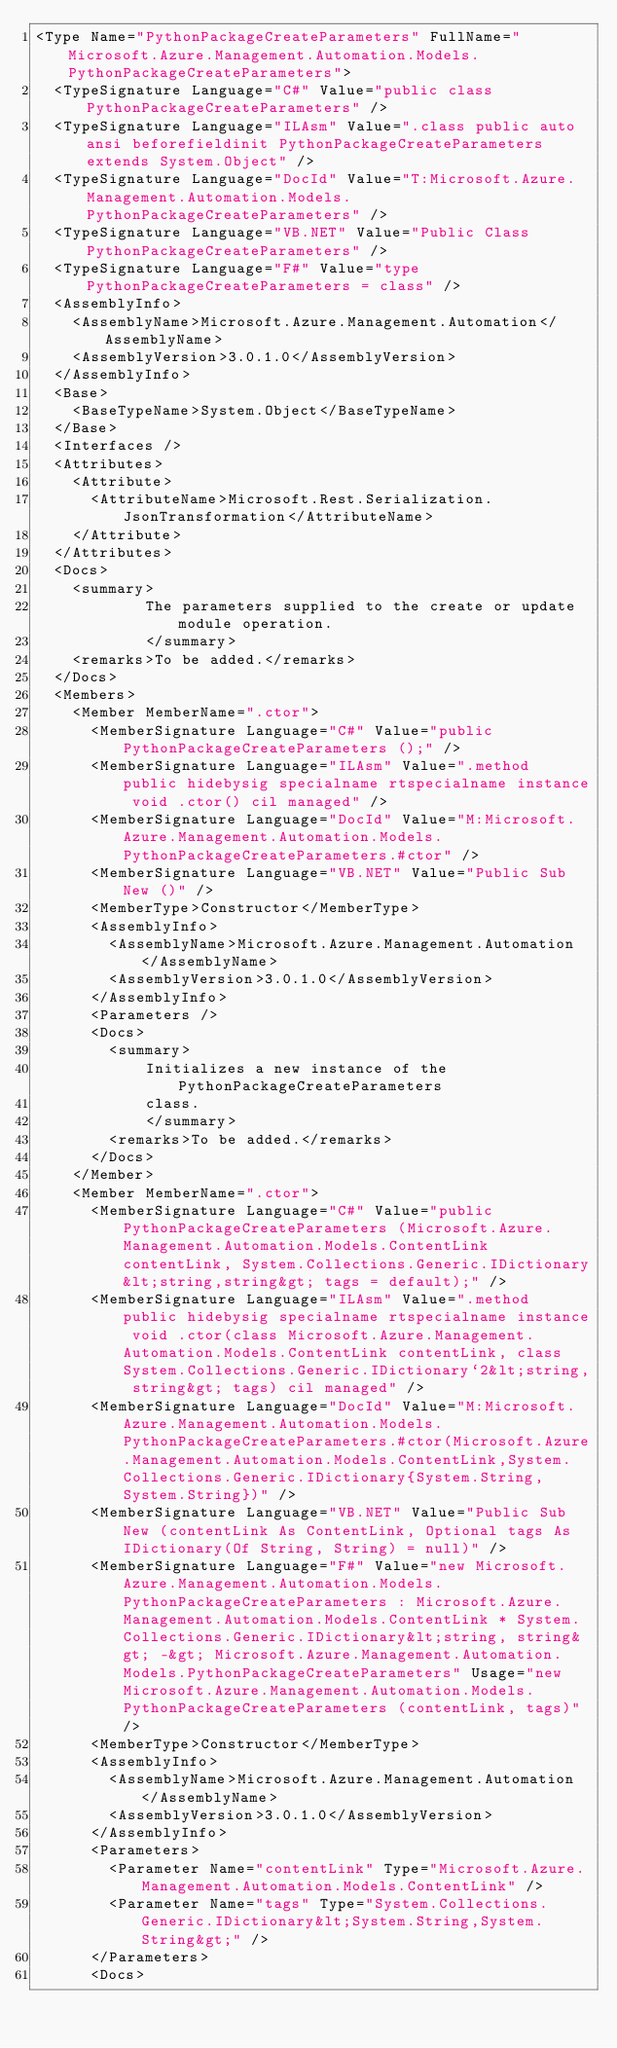<code> <loc_0><loc_0><loc_500><loc_500><_XML_><Type Name="PythonPackageCreateParameters" FullName="Microsoft.Azure.Management.Automation.Models.PythonPackageCreateParameters">
  <TypeSignature Language="C#" Value="public class PythonPackageCreateParameters" />
  <TypeSignature Language="ILAsm" Value=".class public auto ansi beforefieldinit PythonPackageCreateParameters extends System.Object" />
  <TypeSignature Language="DocId" Value="T:Microsoft.Azure.Management.Automation.Models.PythonPackageCreateParameters" />
  <TypeSignature Language="VB.NET" Value="Public Class PythonPackageCreateParameters" />
  <TypeSignature Language="F#" Value="type PythonPackageCreateParameters = class" />
  <AssemblyInfo>
    <AssemblyName>Microsoft.Azure.Management.Automation</AssemblyName>
    <AssemblyVersion>3.0.1.0</AssemblyVersion>
  </AssemblyInfo>
  <Base>
    <BaseTypeName>System.Object</BaseTypeName>
  </Base>
  <Interfaces />
  <Attributes>
    <Attribute>
      <AttributeName>Microsoft.Rest.Serialization.JsonTransformation</AttributeName>
    </Attribute>
  </Attributes>
  <Docs>
    <summary>
            The parameters supplied to the create or update module operation.
            </summary>
    <remarks>To be added.</remarks>
  </Docs>
  <Members>
    <Member MemberName=".ctor">
      <MemberSignature Language="C#" Value="public PythonPackageCreateParameters ();" />
      <MemberSignature Language="ILAsm" Value=".method public hidebysig specialname rtspecialname instance void .ctor() cil managed" />
      <MemberSignature Language="DocId" Value="M:Microsoft.Azure.Management.Automation.Models.PythonPackageCreateParameters.#ctor" />
      <MemberSignature Language="VB.NET" Value="Public Sub New ()" />
      <MemberType>Constructor</MemberType>
      <AssemblyInfo>
        <AssemblyName>Microsoft.Azure.Management.Automation</AssemblyName>
        <AssemblyVersion>3.0.1.0</AssemblyVersion>
      </AssemblyInfo>
      <Parameters />
      <Docs>
        <summary>
            Initializes a new instance of the PythonPackageCreateParameters
            class.
            </summary>
        <remarks>To be added.</remarks>
      </Docs>
    </Member>
    <Member MemberName=".ctor">
      <MemberSignature Language="C#" Value="public PythonPackageCreateParameters (Microsoft.Azure.Management.Automation.Models.ContentLink contentLink, System.Collections.Generic.IDictionary&lt;string,string&gt; tags = default);" />
      <MemberSignature Language="ILAsm" Value=".method public hidebysig specialname rtspecialname instance void .ctor(class Microsoft.Azure.Management.Automation.Models.ContentLink contentLink, class System.Collections.Generic.IDictionary`2&lt;string, string&gt; tags) cil managed" />
      <MemberSignature Language="DocId" Value="M:Microsoft.Azure.Management.Automation.Models.PythonPackageCreateParameters.#ctor(Microsoft.Azure.Management.Automation.Models.ContentLink,System.Collections.Generic.IDictionary{System.String,System.String})" />
      <MemberSignature Language="VB.NET" Value="Public Sub New (contentLink As ContentLink, Optional tags As IDictionary(Of String, String) = null)" />
      <MemberSignature Language="F#" Value="new Microsoft.Azure.Management.Automation.Models.PythonPackageCreateParameters : Microsoft.Azure.Management.Automation.Models.ContentLink * System.Collections.Generic.IDictionary&lt;string, string&gt; -&gt; Microsoft.Azure.Management.Automation.Models.PythonPackageCreateParameters" Usage="new Microsoft.Azure.Management.Automation.Models.PythonPackageCreateParameters (contentLink, tags)" />
      <MemberType>Constructor</MemberType>
      <AssemblyInfo>
        <AssemblyName>Microsoft.Azure.Management.Automation</AssemblyName>
        <AssemblyVersion>3.0.1.0</AssemblyVersion>
      </AssemblyInfo>
      <Parameters>
        <Parameter Name="contentLink" Type="Microsoft.Azure.Management.Automation.Models.ContentLink" />
        <Parameter Name="tags" Type="System.Collections.Generic.IDictionary&lt;System.String,System.String&gt;" />
      </Parameters>
      <Docs></code> 